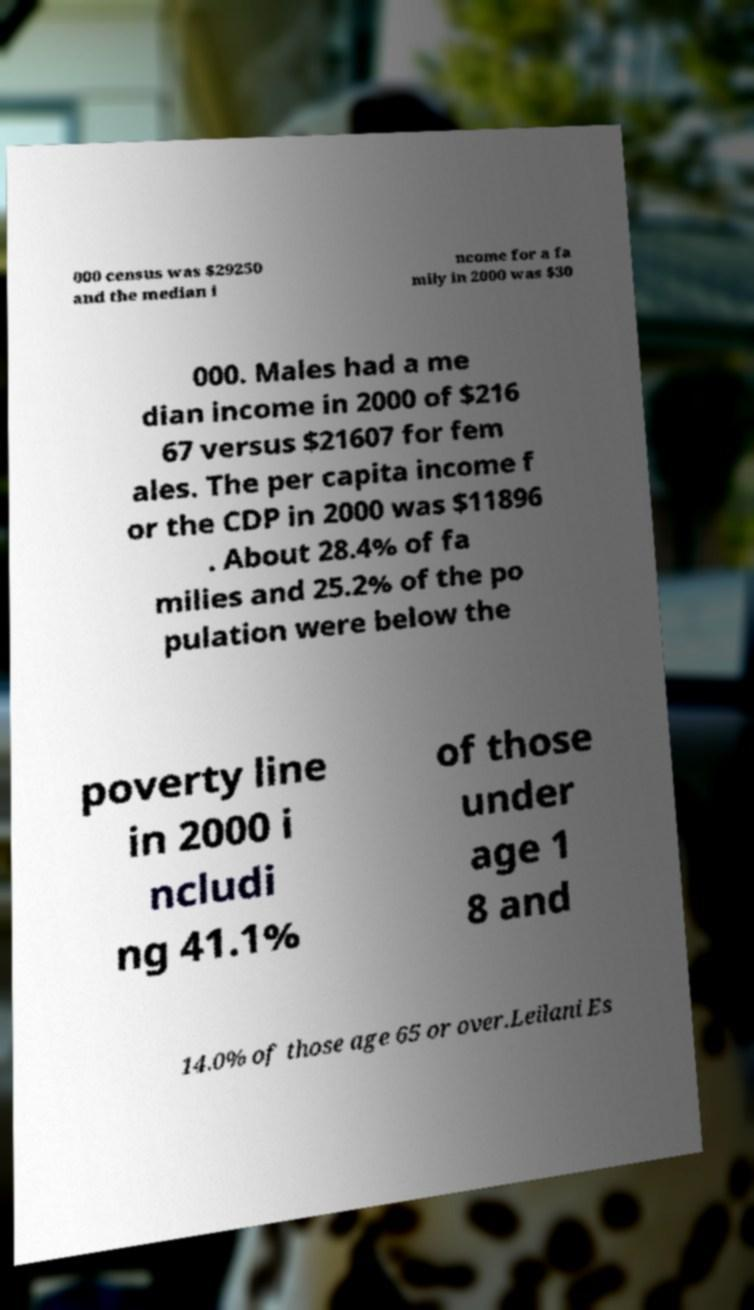What messages or text are displayed in this image? I need them in a readable, typed format. 000 census was $29250 and the median i ncome for a fa mily in 2000 was $30 000. Males had a me dian income in 2000 of $216 67 versus $21607 for fem ales. The per capita income f or the CDP in 2000 was $11896 . About 28.4% of fa milies and 25.2% of the po pulation were below the poverty line in 2000 i ncludi ng 41.1% of those under age 1 8 and 14.0% of those age 65 or over.Leilani Es 